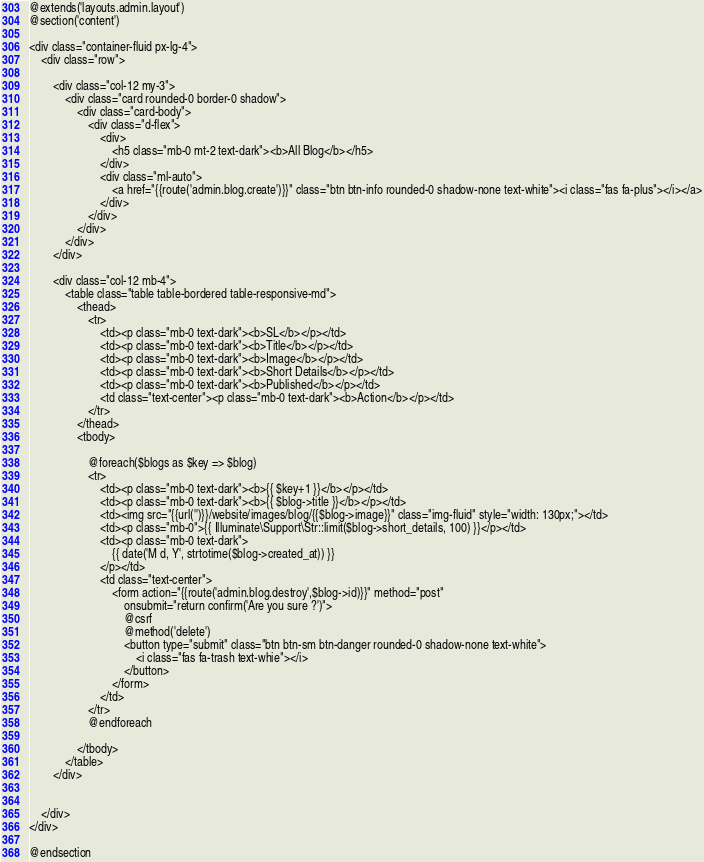<code> <loc_0><loc_0><loc_500><loc_500><_PHP_>
@extends('layouts.admin.layout')
@section('content')

<div class="container-fluid px-lg-4">
    <div class="row">

        <div class="col-12 my-3">
            <div class="card rounded-0 border-0 shadow">
                <div class="card-body">
                    <div class="d-flex">
                        <div>
                            <h5 class="mb-0 mt-2 text-dark"><b>All Blog</b></h5>
                        </div>
                        <div class="ml-auto">
                            <a href="{{route('admin.blog.create')}}" class="btn btn-info rounded-0 shadow-none text-white"><i class="fas fa-plus"></i></a>
                        </div>
                    </div>
                </div>
            </div>
        </div>

        <div class="col-12 mb-4">
            <table class="table table-bordered table-responsive-md">
                <thead>
                    <tr>
                        <td><p class="mb-0 text-dark"><b>SL</b></p></td>
                        <td><p class="mb-0 text-dark"><b>Title</b></p></td>
                        <td><p class="mb-0 text-dark"><b>Image</b></p></td>
                        <td><p class="mb-0 text-dark"><b>Short Details</b></p></td>
                        <td><p class="mb-0 text-dark"><b>Published</b></p></td>
                        <td class="text-center"><p class="mb-0 text-dark"><b>Action</b></p></td>
                    </tr>
                </thead>
                <tbody>

                    @foreach($blogs as $key => $blog)
                    <tr>
                        <td><p class="mb-0 text-dark"><b>{{ $key+1 }}</b></p></td>
                        <td><p class="mb-0 text-dark"><b>{{ $blog->title }}</b></p></td>
                        <td><img src="{{url('')}}/website/images/blog/{{$blog->image}}" class="img-fluid" style="width: 130px;"></td>
                        <td><p class="mb-0">{{ Illuminate\Support\Str::limit($blog->short_details, 100) }}</p></td>
                        <td><p class="mb-0 text-dark">
                            {{ date('M d, Y', strtotime($blog->created_at)) }}
                        </p></td>
                        <td class="text-center">
                            <form action="{{route('admin.blog.destroy',$blog->id)}}" method="post"
                                onsubmit="return confirm('Are you sure ?')">
                                @csrf
                                @method('delete')
                                <button type="submit" class="btn btn-sm btn-danger rounded-0 shadow-none text-white">
                                    <i class="fas fa-trash text-whie"></i>
                                </button>
                            </form>
                        </td>
                    </tr>
                    @endforeach

                </tbody>
            </table>
        </div>


    </div>
</div>

@endsection</code> 